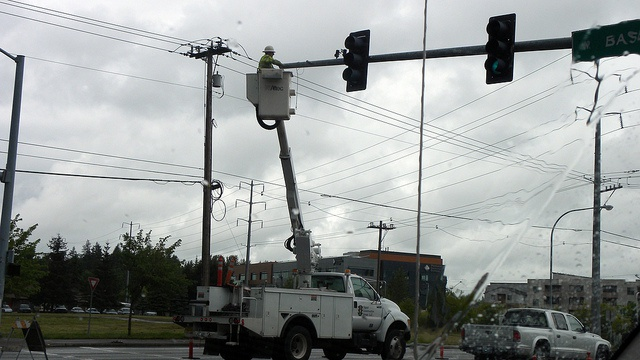Describe the objects in this image and their specific colors. I can see truck in lightgray, black, gray, and darkgray tones, truck in lightgray, black, gray, and darkgray tones, traffic light in lightgray, black, gray, and teal tones, traffic light in lightgray, black, gray, and darkgray tones, and people in lightgray, black, gray, darkgreen, and darkgray tones in this image. 